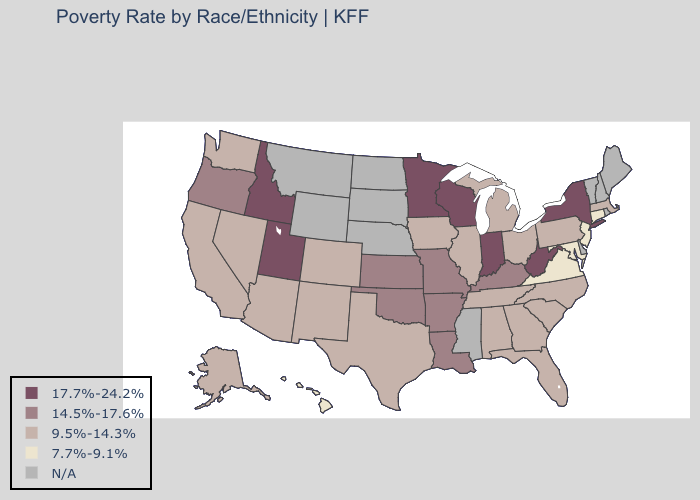What is the value of Kansas?
Quick response, please. 14.5%-17.6%. Which states have the highest value in the USA?
Give a very brief answer. Idaho, Indiana, Minnesota, New York, Utah, West Virginia, Wisconsin. Which states hav the highest value in the Northeast?
Short answer required. New York. Does Florida have the lowest value in the South?
Short answer required. No. Does the first symbol in the legend represent the smallest category?
Short answer required. No. Which states have the lowest value in the South?
Be succinct. Maryland, Virginia. Among the states that border Utah , which have the lowest value?
Be succinct. Arizona, Colorado, Nevada, New Mexico. Does Connecticut have the highest value in the Northeast?
Short answer required. No. Name the states that have a value in the range 7.7%-9.1%?
Answer briefly. Connecticut, Hawaii, Maryland, New Jersey, Virginia. Among the states that border Montana , which have the highest value?
Keep it brief. Idaho. What is the value of North Dakota?
Short answer required. N/A. Among the states that border North Carolina , which have the lowest value?
Concise answer only. Virginia. How many symbols are there in the legend?
Concise answer only. 5. What is the value of Oregon?
Answer briefly. 14.5%-17.6%. 